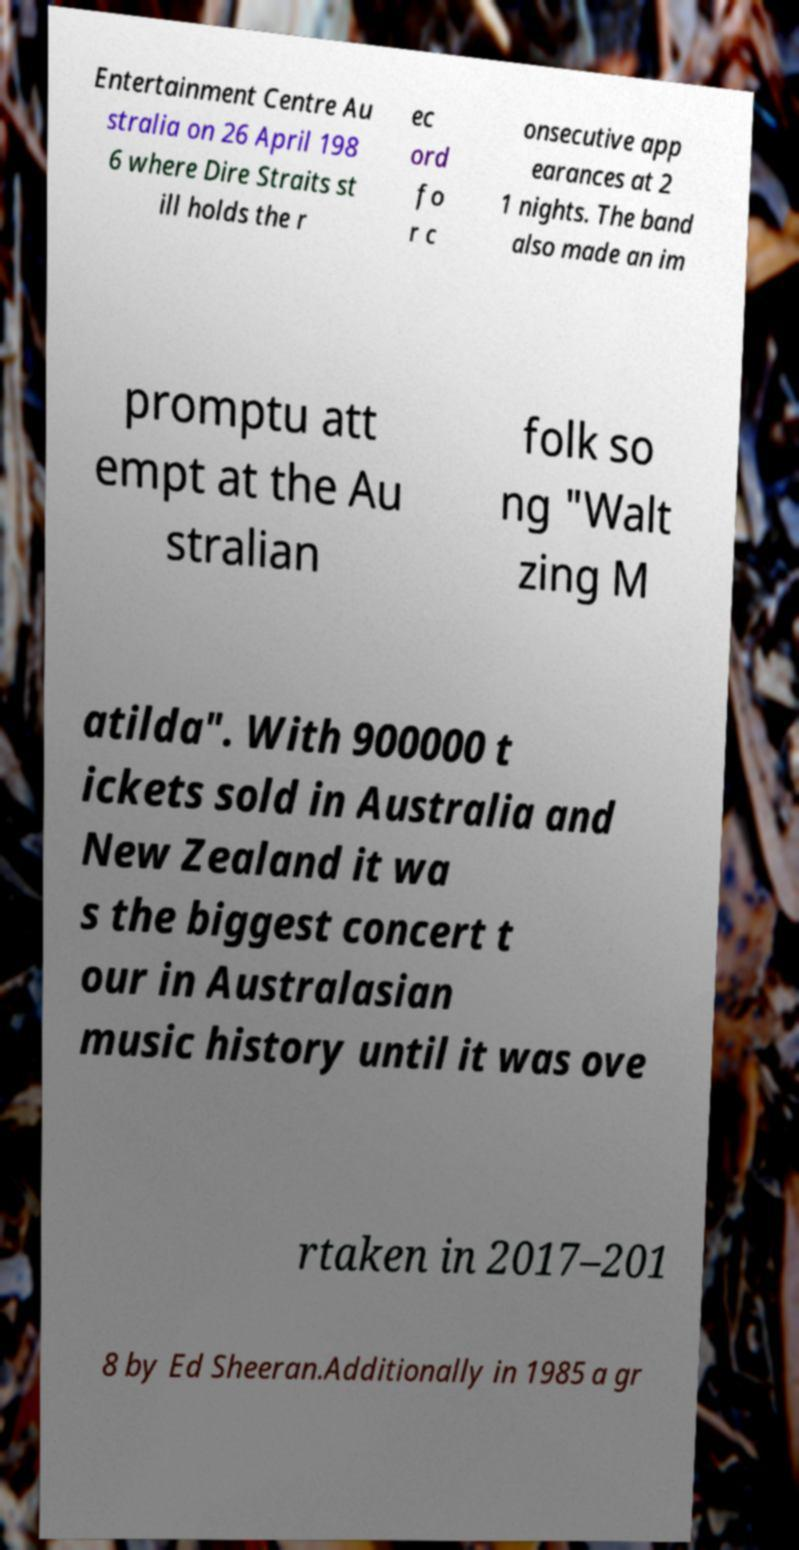Can you accurately transcribe the text from the provided image for me? Entertainment Centre Au stralia on 26 April 198 6 where Dire Straits st ill holds the r ec ord fo r c onsecutive app earances at 2 1 nights. The band also made an im promptu att empt at the Au stralian folk so ng "Walt zing M atilda". With 900000 t ickets sold in Australia and New Zealand it wa s the biggest concert t our in Australasian music history until it was ove rtaken in 2017–201 8 by Ed Sheeran.Additionally in 1985 a gr 